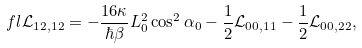Convert formula to latex. <formula><loc_0><loc_0><loc_500><loc_500>\ f l \mathcal { L } _ { 1 2 , 1 2 } = - \frac { 1 6 \kappa } { \hbar { \beta } } L _ { 0 } ^ { 2 } \cos ^ { 2 } \alpha _ { 0 } - \frac { 1 } { 2 } \mathcal { L } _ { 0 0 , 1 1 } - \frac { 1 } { 2 } \mathcal { L } _ { 0 0 , 2 2 } ,</formula> 